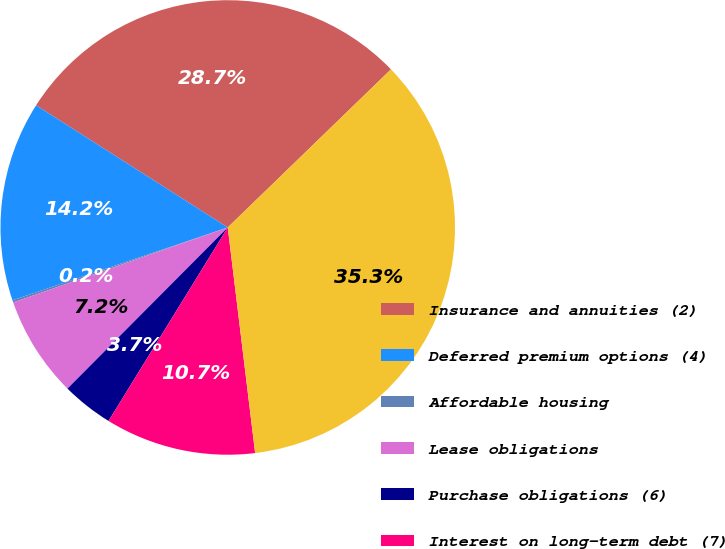Convert chart to OTSL. <chart><loc_0><loc_0><loc_500><loc_500><pie_chart><fcel>Insurance and annuities (2)<fcel>Deferred premium options (4)<fcel>Affordable housing<fcel>Lease obligations<fcel>Purchase obligations (6)<fcel>Interest on long-term debt (7)<fcel>Total<nl><fcel>28.72%<fcel>14.22%<fcel>0.16%<fcel>7.19%<fcel>3.67%<fcel>10.71%<fcel>35.32%<nl></chart> 